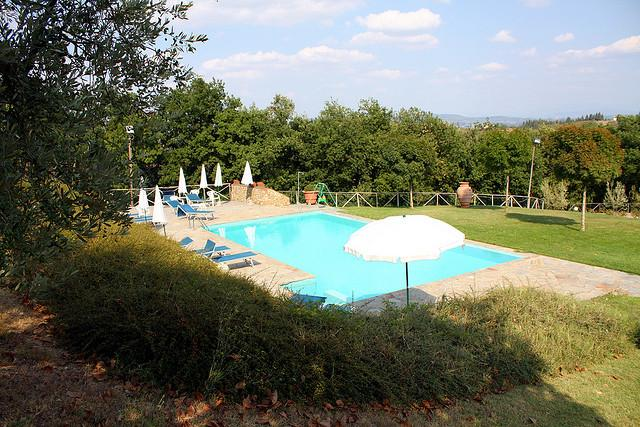Where is this pool located at? park 